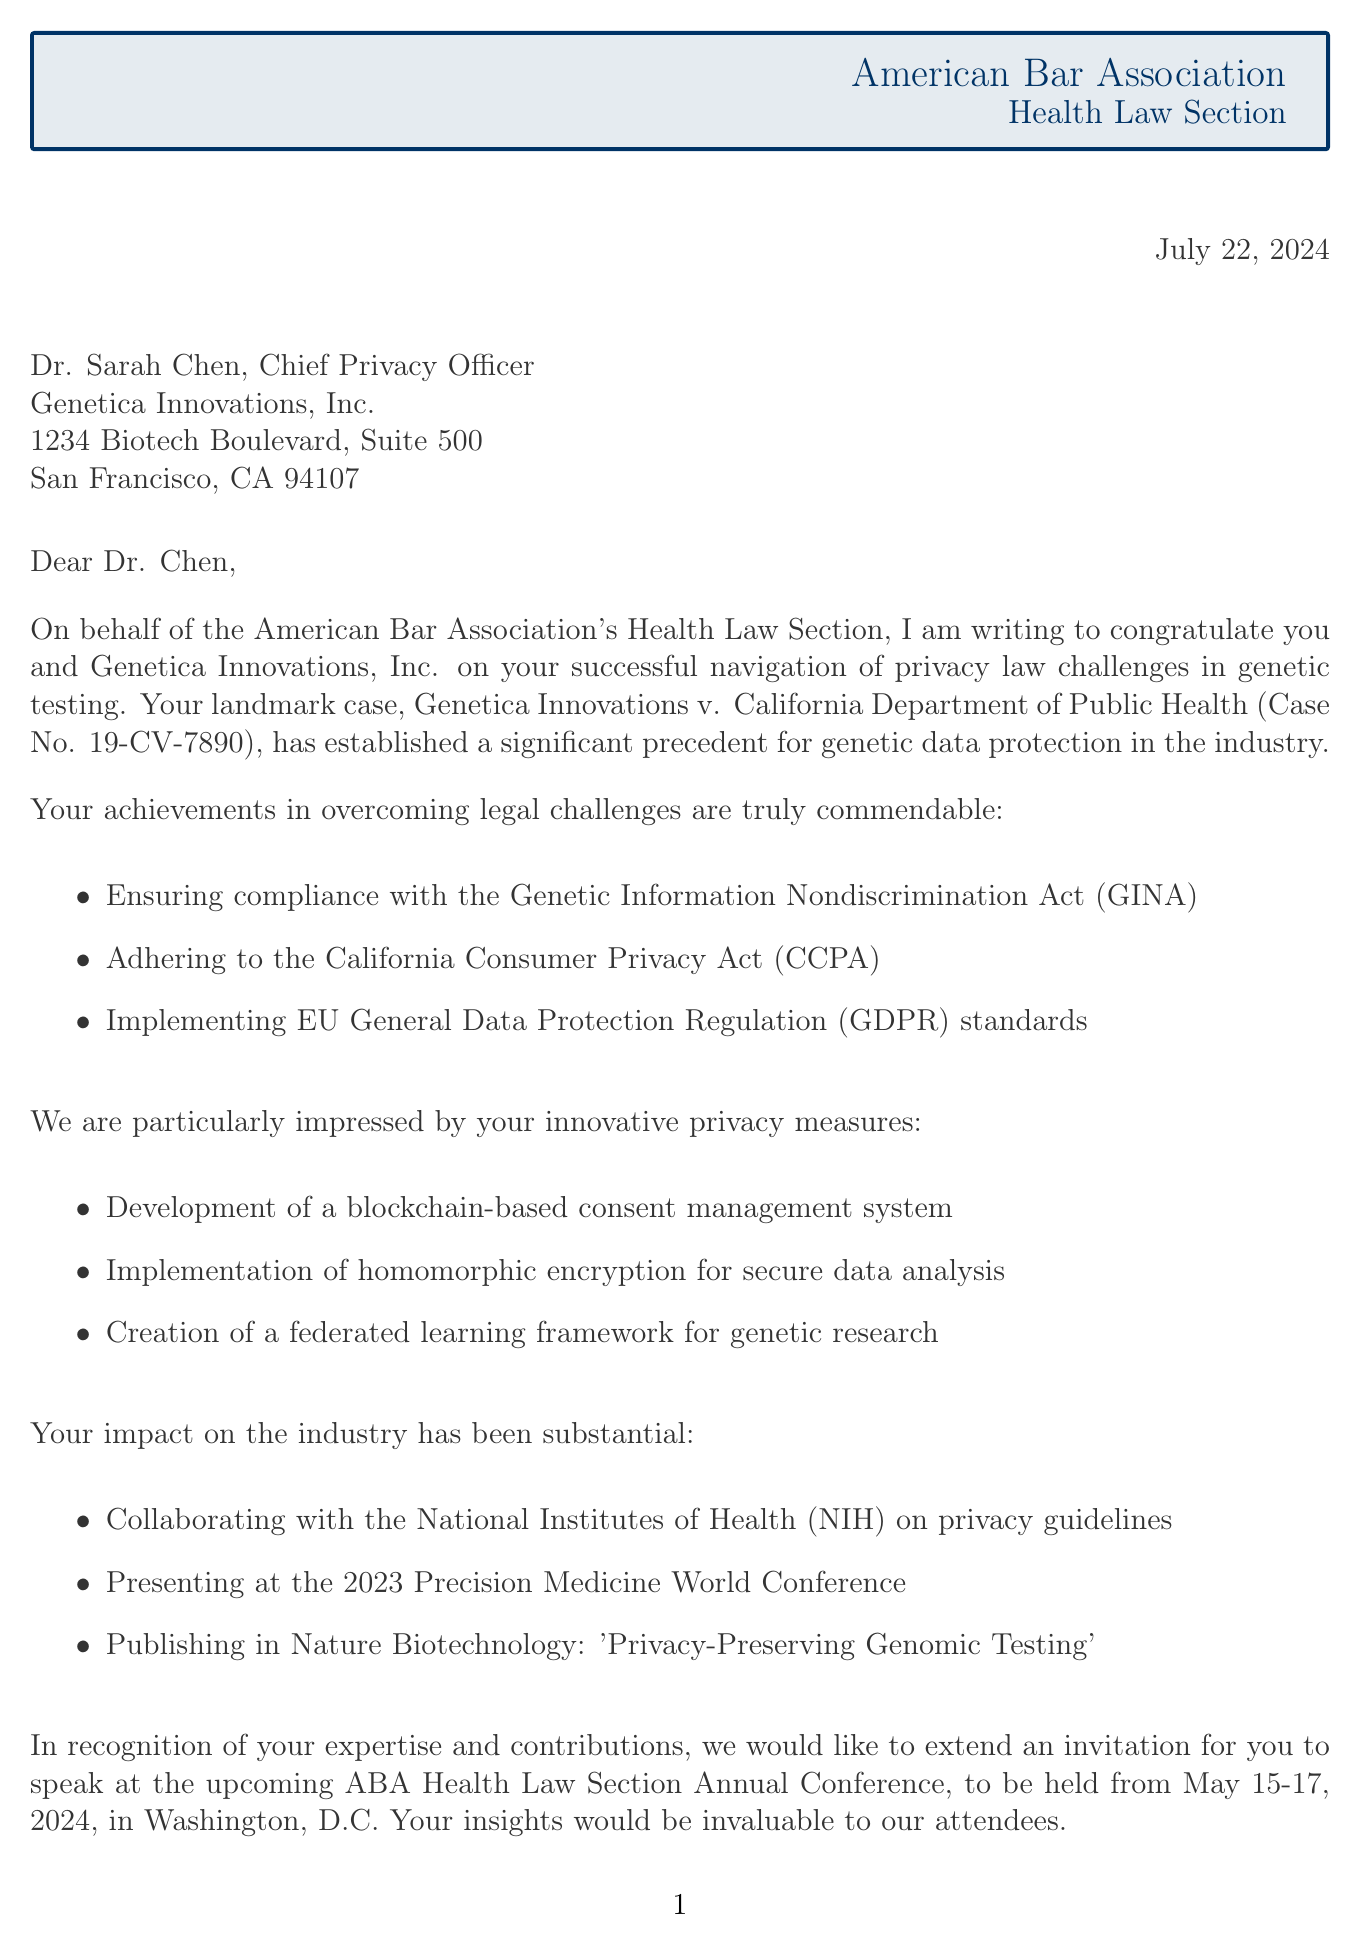What is the sender's name? The sender's name is included in the letter's header as the American Bar Association - Health Law Section.
Answer: American Bar Association - Health Law Section Who is the addressee of the letter? The letter specifies Dr. Sarah Chen as the addressee in the address section.
Answer: Dr. Sarah Chen What case is mentioned in the letter? The case referenced in the letter is part of the opening paragraph detailing the achievement.
Answer: Genetica Innovations v. California Department of Public Health What is the date of the upcoming conference? The closing paragraph states the dates for the upcoming conference.
Answer: May 15-17, 2024 How many legal challenges are listed in the letter? The body paragraphs detail the legal challenges overcome, listing them explicitly.
Answer: three What innovative measure involves blockchain technology? The letter mentions a specific innovative privacy measure related to blockchain.
Answer: Development of a blockchain-based consent management system What publication is referenced in the letter? The letter identifies a specific publication related to the industry impact of the company.
Answer: Privacy-Preserving Genomic Testing Who signed the letter? The signature section indicates who signed the letter and their position.
Answer: Jennifer L. Geetter, Chair, ABA Health Law Section In what city will the conference take place? The closing paragraph indicates the conference's location, which is mentioned as part of the invitation.
Answer: Washington, D.C 